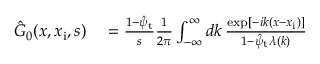<formula> <loc_0><loc_0><loc_500><loc_500>\begin{array} { r l } { \hat { G } _ { 0 } ( x , x _ { i } , s ) } & = \frac { 1 - \hat { \psi } _ { t } } { s } \frac { 1 } { 2 \pi } \int _ { - \infty } ^ { \infty } d k \, \frac { \exp [ - i k ( x - x _ { i } ) ] } { 1 - \hat { \psi } _ { t } \lambda ( k ) } } \end{array}</formula> 